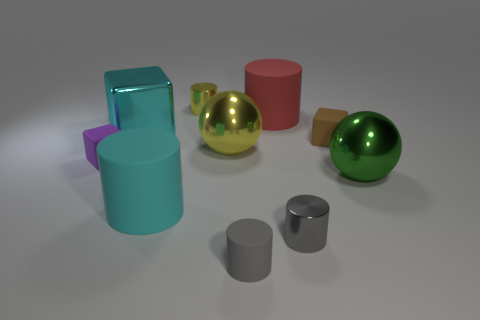There is a shiny object in front of the large green thing; is it the same shape as the big cyan rubber object?
Your answer should be very brief. Yes. Is the number of tiny yellow cylinders that are in front of the red object greater than the number of large cylinders?
Offer a terse response. No. There is a large cylinder to the left of the tiny thing behind the big cyan metallic thing; what color is it?
Your response must be concise. Cyan. What number of rubber blocks are there?
Give a very brief answer. 2. What number of large matte cylinders are to the left of the small yellow metal cylinder and behind the cyan shiny thing?
Provide a succinct answer. 0. Is there any other thing that is the same shape as the large yellow shiny thing?
Your answer should be compact. Yes. There is a large cube; does it have the same color as the big matte cylinder to the right of the cyan cylinder?
Provide a succinct answer. No. What is the shape of the tiny matte object that is left of the large cyan matte cylinder?
Make the answer very short. Cube. How many other objects are the same material as the small brown thing?
Give a very brief answer. 4. What is the material of the yellow ball?
Provide a succinct answer. Metal. 